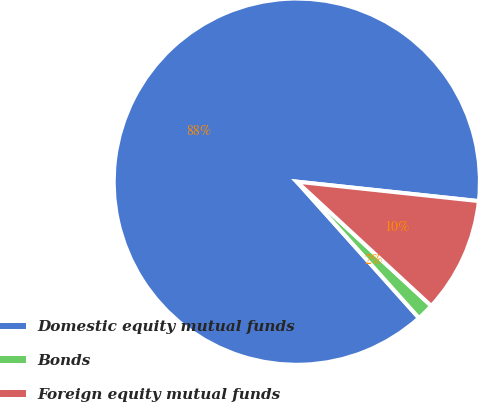Convert chart. <chart><loc_0><loc_0><loc_500><loc_500><pie_chart><fcel>Domestic equity mutual funds<fcel>Bonds<fcel>Foreign equity mutual funds<nl><fcel>88.32%<fcel>1.5%<fcel>10.18%<nl></chart> 